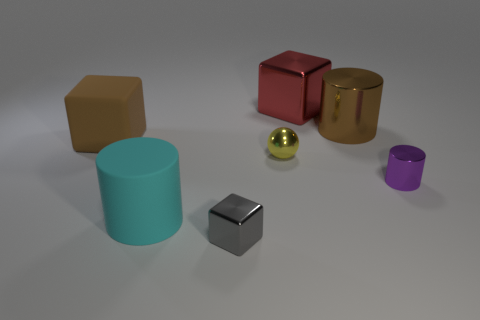Subtract all metal blocks. How many blocks are left? 1 Add 2 tiny yellow rubber spheres. How many objects exist? 9 Subtract all cubes. How many objects are left? 4 Add 5 brown objects. How many brown objects exist? 7 Subtract 1 purple cylinders. How many objects are left? 6 Subtract all large green shiny spheres. Subtract all tiny gray cubes. How many objects are left? 6 Add 1 cylinders. How many cylinders are left? 4 